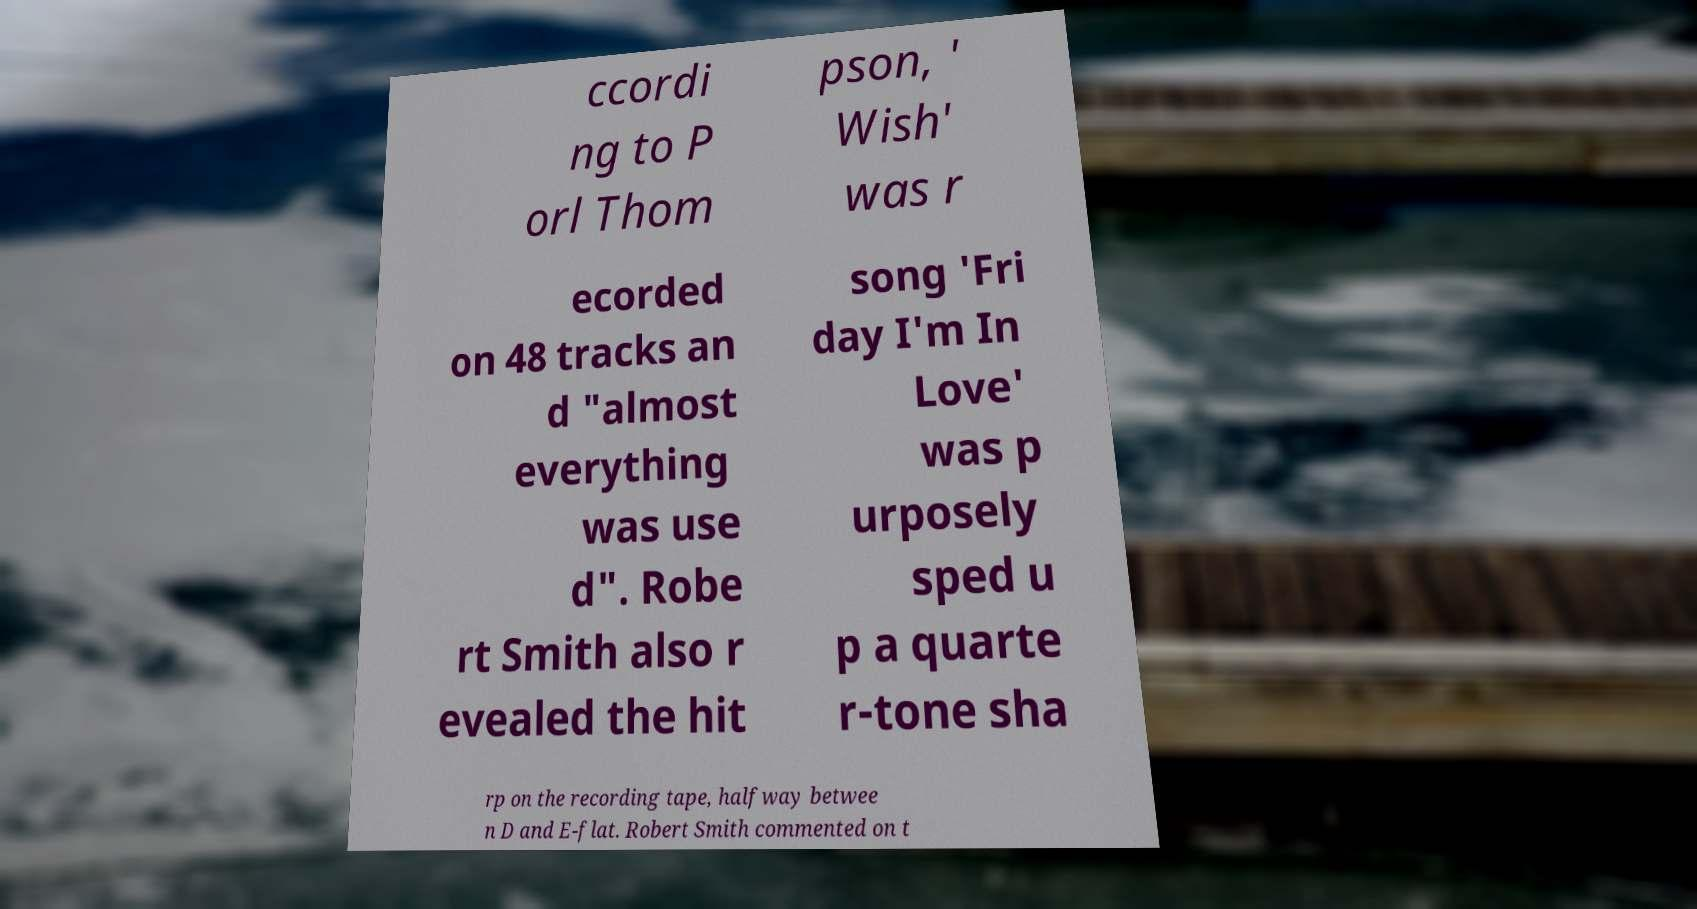Can you accurately transcribe the text from the provided image for me? ccordi ng to P orl Thom pson, ' Wish' was r ecorded on 48 tracks an d "almost everything was use d". Robe rt Smith also r evealed the hit song 'Fri day I'm In Love' was p urposely sped u p a quarte r-tone sha rp on the recording tape, halfway betwee n D and E-flat. Robert Smith commented on t 